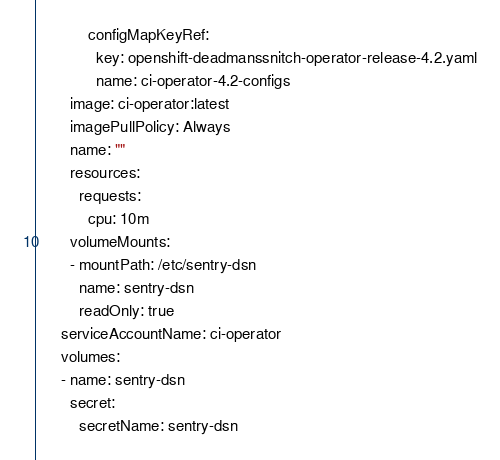<code> <loc_0><loc_0><loc_500><loc_500><_YAML_>            configMapKeyRef:
              key: openshift-deadmanssnitch-operator-release-4.2.yaml
              name: ci-operator-4.2-configs
        image: ci-operator:latest
        imagePullPolicy: Always
        name: ""
        resources:
          requests:
            cpu: 10m
        volumeMounts:
        - mountPath: /etc/sentry-dsn
          name: sentry-dsn
          readOnly: true
      serviceAccountName: ci-operator
      volumes:
      - name: sentry-dsn
        secret:
          secretName: sentry-dsn
</code> 